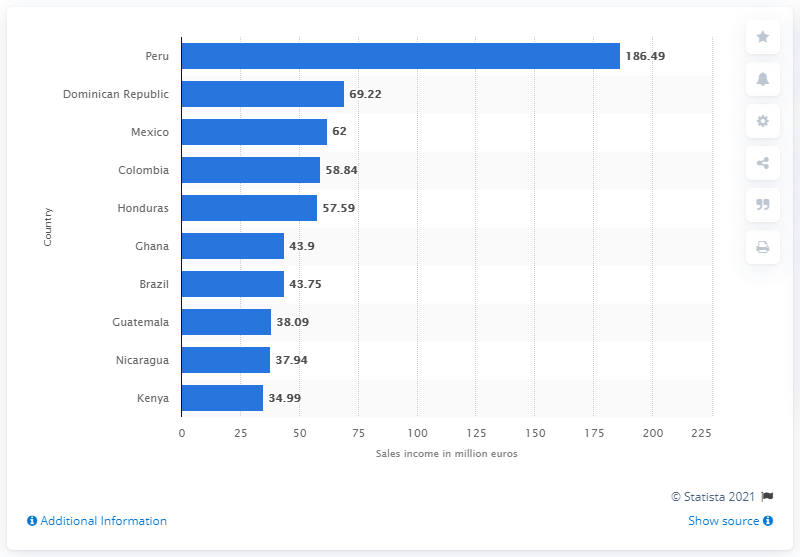List a handful of essential elements in this visual. In 2012, Peru's Fairtrade International sales income was 186.49 million dollars. Peru was the leading country in terms of Fairtrade International sales income in 2012. 